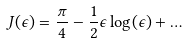Convert formula to latex. <formula><loc_0><loc_0><loc_500><loc_500>J ( \epsilon ) = \frac { \pi } { 4 } - \frac { 1 } { 2 } \epsilon \log ( \epsilon ) + \dots</formula> 